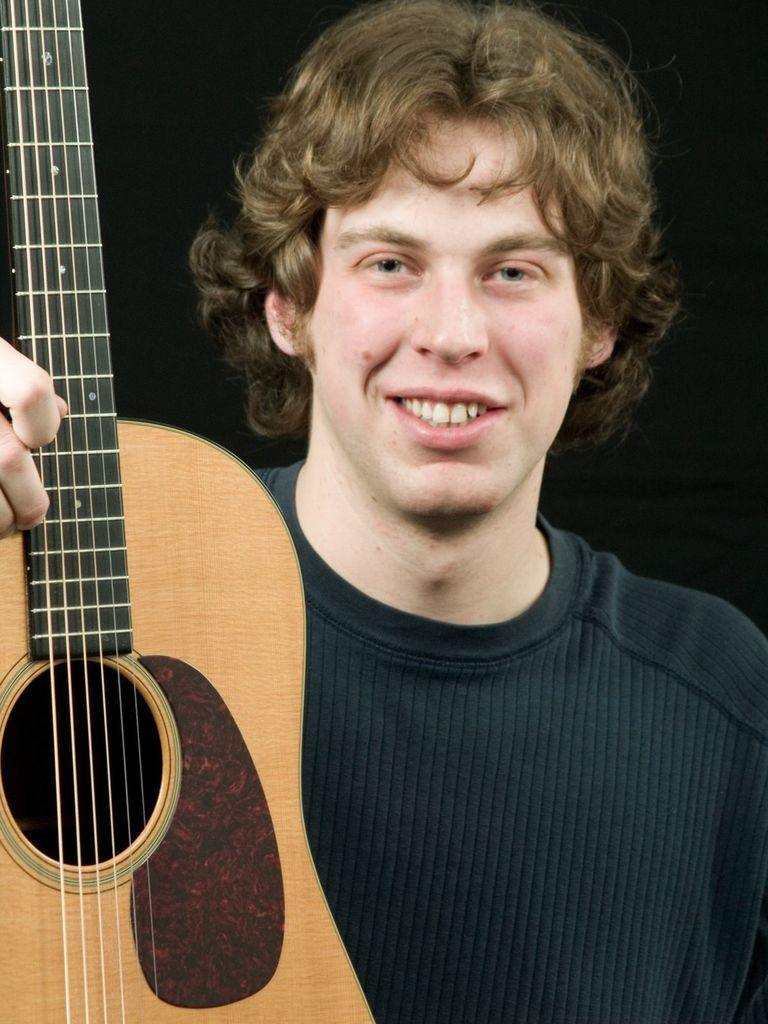What is the person in the image doing? The person is holding a guitar and moving the strings of the guitar. What is the person wearing in the image? The person is wearing a black t-shirt. What is the person's facial expression in the image? The person is smiling. What is the color of the background in the image? The background of the image is black in color. What type of smell can be detected in the image? There is no information about any smell in the image, as it focuses on the person holding a guitar and the background. 